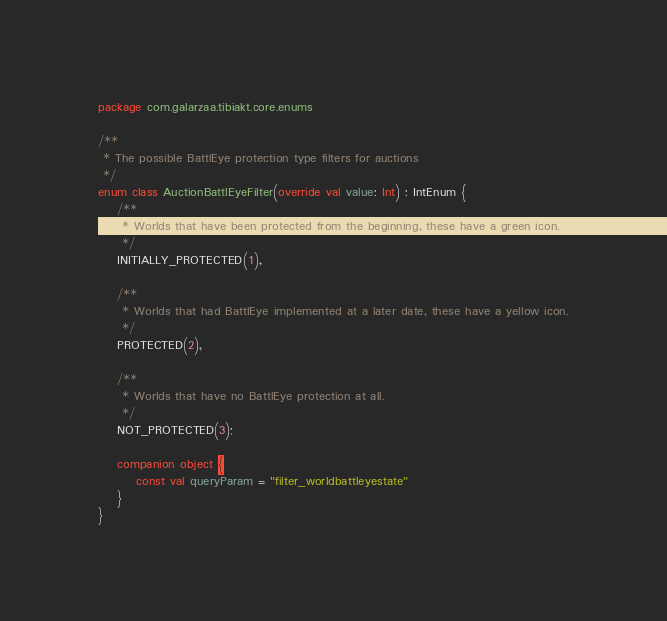Convert code to text. <code><loc_0><loc_0><loc_500><loc_500><_Kotlin_>package com.galarzaa.tibiakt.core.enums

/**
 * The possible BattlEye protection type filters for auctions
 */
enum class AuctionBattlEyeFilter(override val value: Int) : IntEnum {
    /**
     * Worlds that have been protected from the beginning, these have a green icon.
     */
    INITIALLY_PROTECTED(1),

    /**
     * Worlds that had BattlEye implemented at a later date, these have a yellow icon.
     */
    PROTECTED(2),

    /**
     * Worlds that have no BattlEye protection at all.
     */
    NOT_PROTECTED(3);

    companion object {
        const val queryParam = "filter_worldbattleyestate"
    }
}</code> 